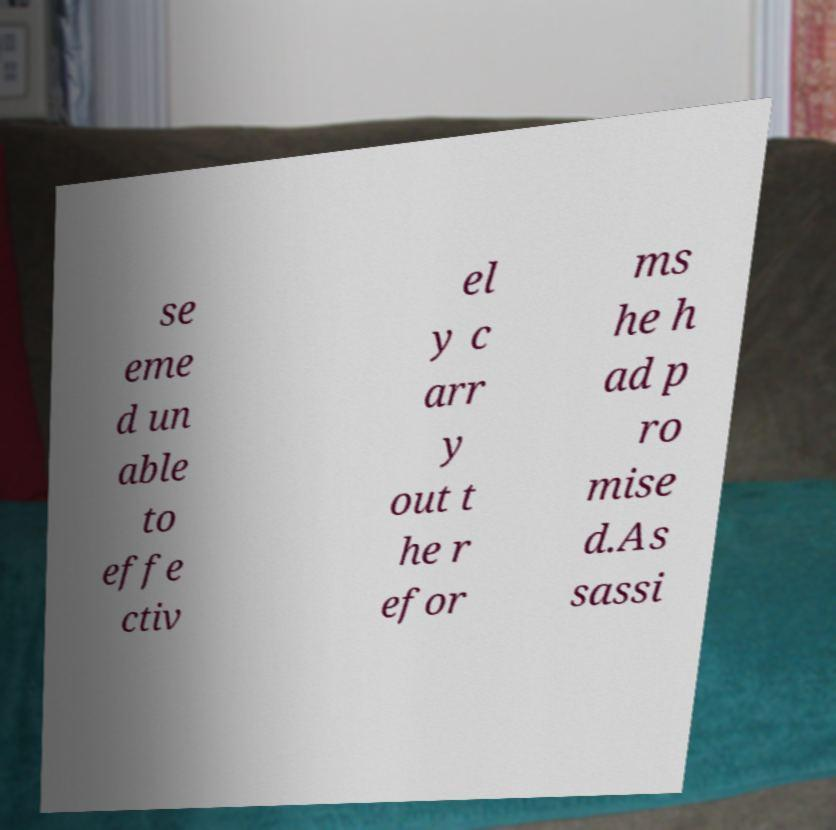Please read and relay the text visible in this image. What does it say? se eme d un able to effe ctiv el y c arr y out t he r efor ms he h ad p ro mise d.As sassi 